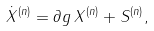Convert formula to latex. <formula><loc_0><loc_0><loc_500><loc_500>\dot { X } ^ { ( n ) } = \partial g \, X ^ { ( n ) } + S ^ { ( n ) } ,</formula> 